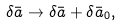<formula> <loc_0><loc_0><loc_500><loc_500>\delta \bar { a } \to \delta \bar { a } + \delta \bar { a } _ { 0 } ,</formula> 